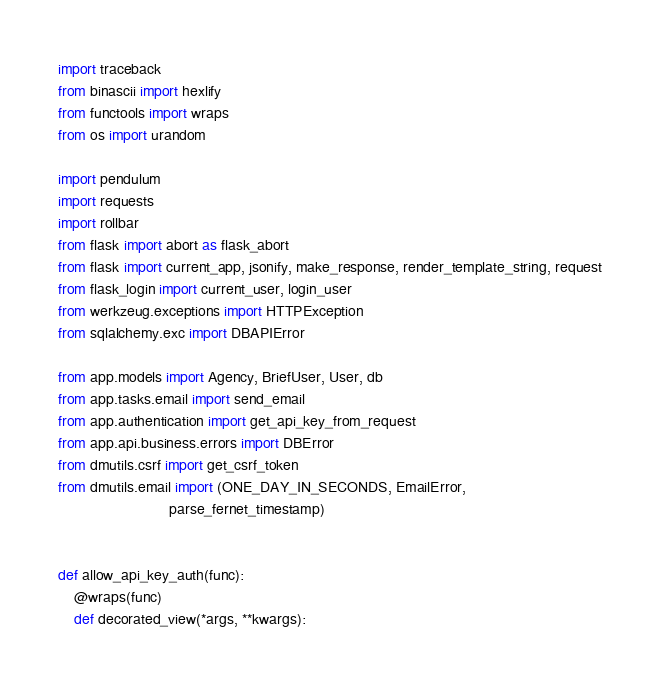Convert code to text. <code><loc_0><loc_0><loc_500><loc_500><_Python_>import traceback
from binascii import hexlify
from functools import wraps
from os import urandom

import pendulum
import requests
import rollbar
from flask import abort as flask_abort
from flask import current_app, jsonify, make_response, render_template_string, request
from flask_login import current_user, login_user
from werkzeug.exceptions import HTTPException
from sqlalchemy.exc import DBAPIError

from app.models import Agency, BriefUser, User, db
from app.tasks.email import send_email
from app.authentication import get_api_key_from_request
from app.api.business.errors import DBError
from dmutils.csrf import get_csrf_token
from dmutils.email import (ONE_DAY_IN_SECONDS, EmailError,
                           parse_fernet_timestamp)


def allow_api_key_auth(func):
    @wraps(func)
    def decorated_view(*args, **kwargs):</code> 